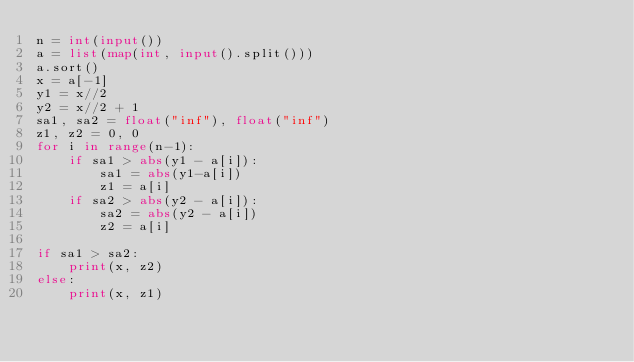Convert code to text. <code><loc_0><loc_0><loc_500><loc_500><_Python_>n = int(input())
a = list(map(int, input().split()))
a.sort()
x = a[-1]
y1 = x//2
y2 = x//2 + 1
sa1, sa2 = float("inf"), float("inf")
z1, z2 = 0, 0
for i in range(n-1):
    if sa1 > abs(y1 - a[i]):
        sa1 = abs(y1-a[i])
        z1 = a[i]
    if sa2 > abs(y2 - a[i]):
        sa2 = abs(y2 - a[i])
        z2 = a[i]

if sa1 > sa2:
    print(x, z2)
else:
    print(x, z1)


</code> 